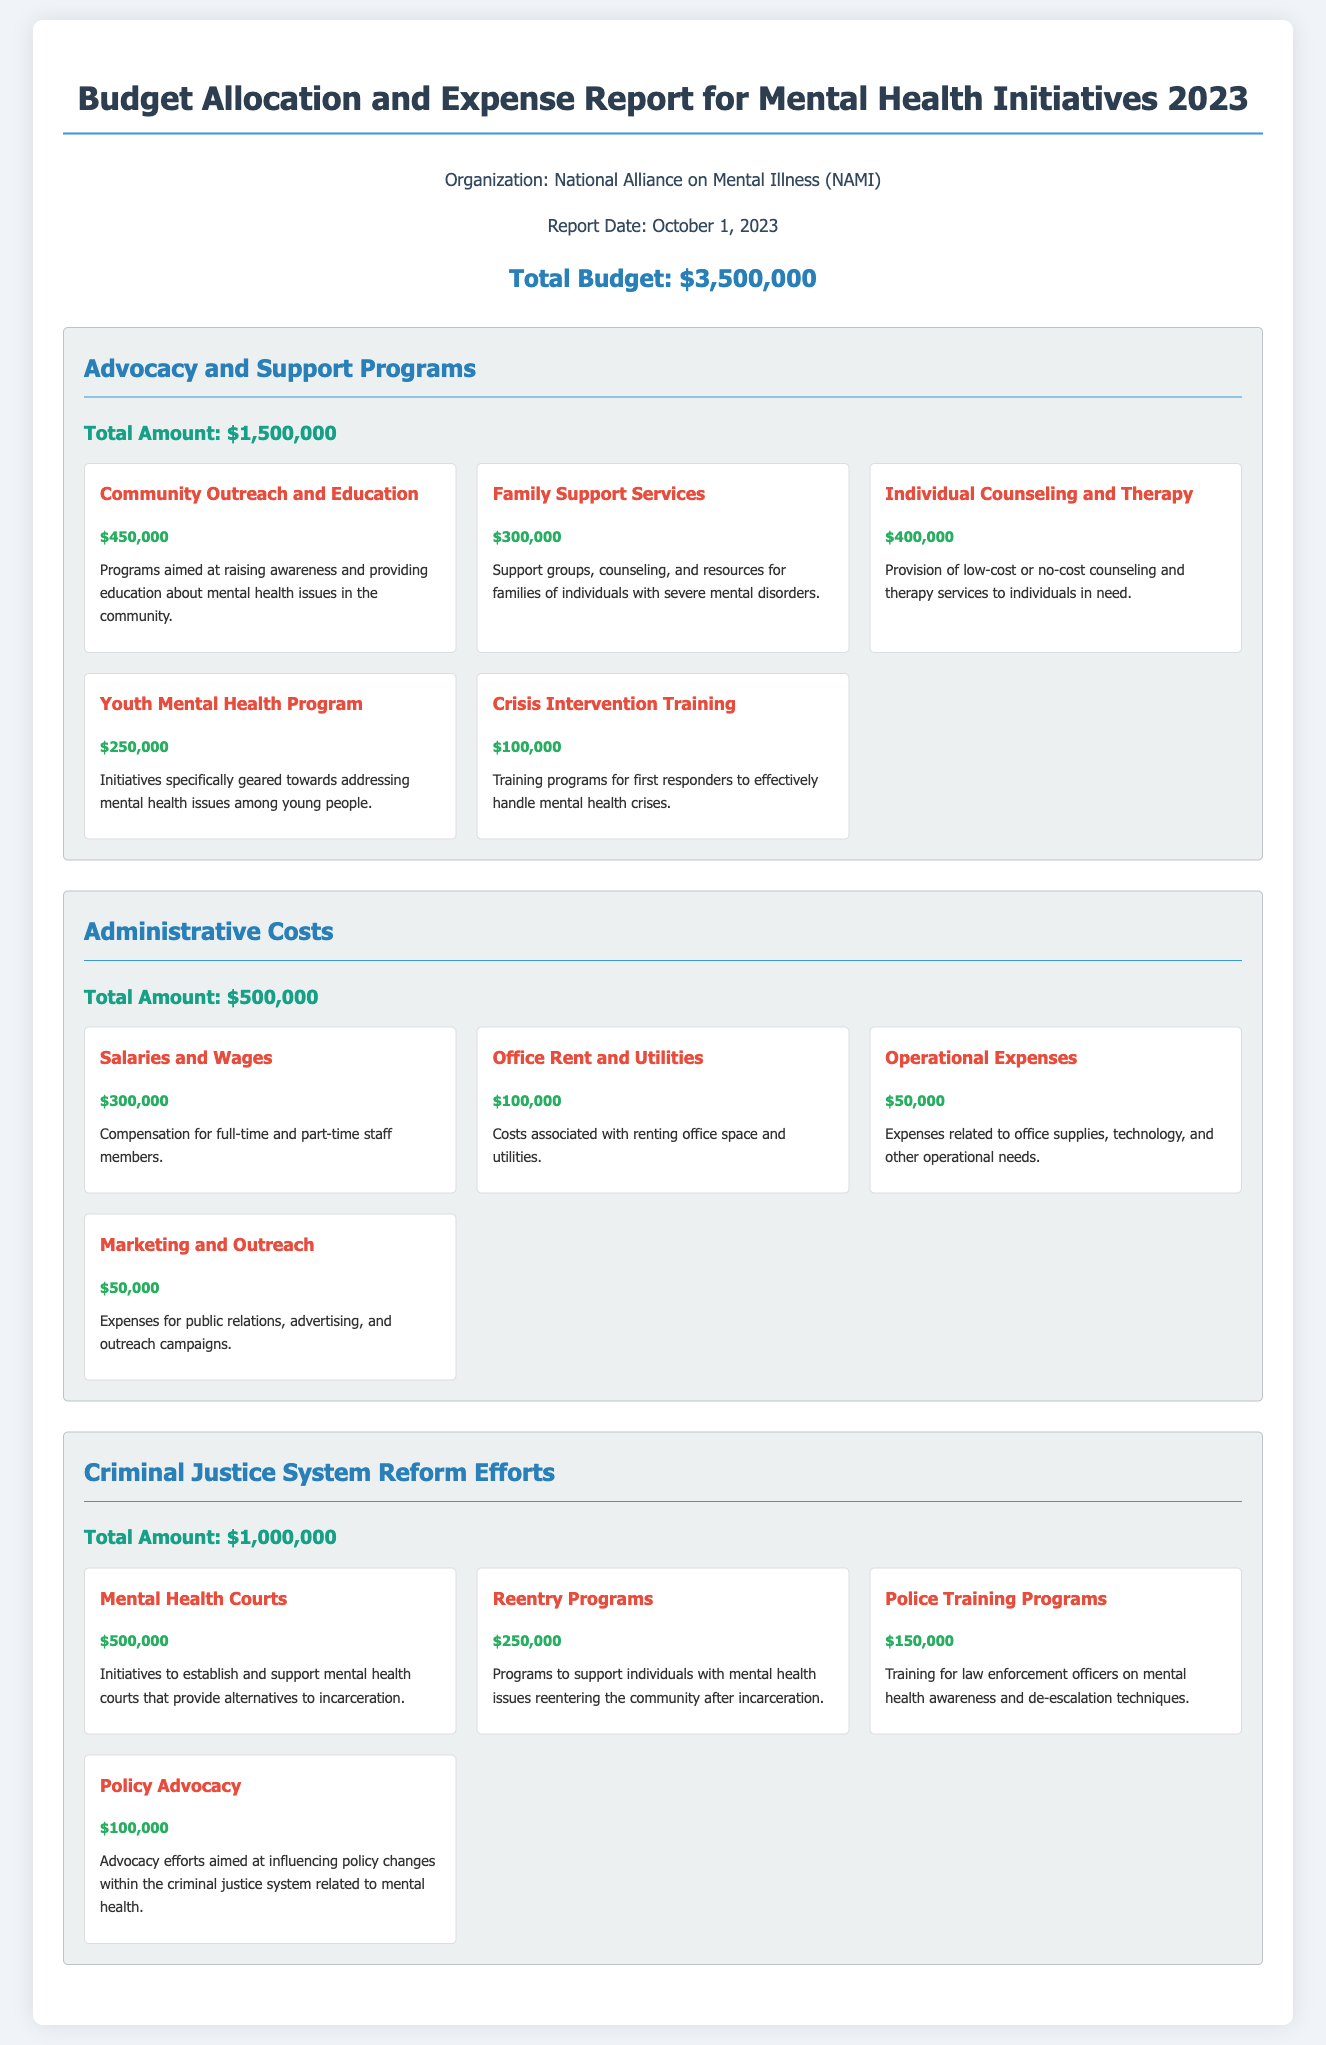what is the total budget for mental health initiatives in 2023? The total budget is explicitly stated in the document.
Answer: $3,500,000 how much funding is allocated for advocacy and support programs? This amount is provided under the section for advocacy and support.
Answer: $1,500,000 how much is allocated for mental health courts? The specific amount for mental health courts is detailed in the criminal justice system reform efforts section.
Answer: $500,000 what percentage of the total budget is spent on administrative costs? Administrative costs are given in the budget, and can be calculated as $500,000 out of $3,500,000.
Answer: 14.3% name one program aimed at youth mental health issues. The name of the program is included in the advocacy and support programs section.
Answer: Youth Mental Health Program what is the total amount allocated for police training programs? This amount is listed in the criminal justice system reform efforts section.
Answer: $150,000 how many advocacy and support programs are listed in the document? The number of programs is inferred from the breakdown of the advocacy section.
Answer: 5 which item has the highest funding within the criminal justice system reform efforts? The highest funded item can be identified from the listed amounts in that section.
Answer: Mental Health Courts what type of costs does the administrative section mainly refer to? This is indicated by the defined categories within that section.
Answer: Salaries and Wages 